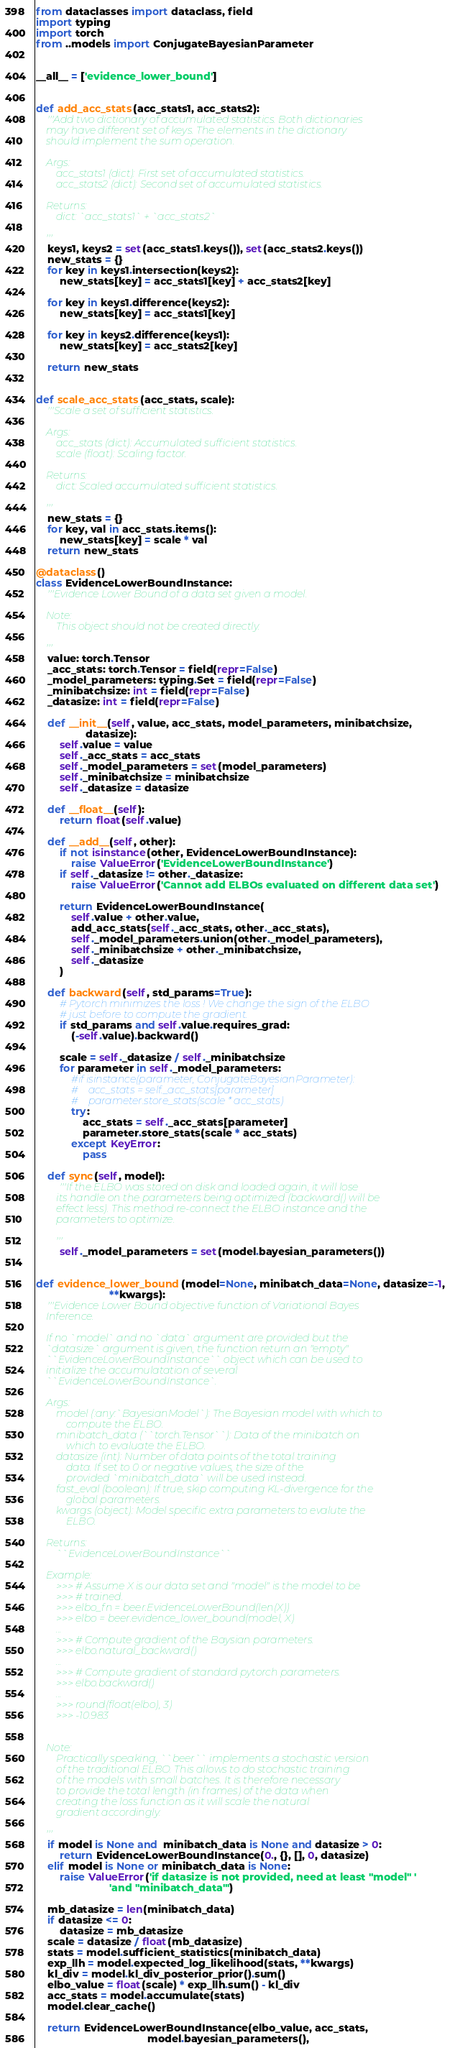Convert code to text. <code><loc_0><loc_0><loc_500><loc_500><_Python_>from dataclasses import dataclass, field
import typing
import torch
from ..models import ConjugateBayesianParameter


__all__ = ['evidence_lower_bound']


def add_acc_stats(acc_stats1, acc_stats2):
    '''Add two dictionary of accumulated statistics. Both dictionaries
    may have different set of keys. The elements in the dictionary
    should implement the sum operation.

    Args:
        acc_stats1 (dict): First set of accumulated statistics.
        acc_stats2 (dict): Second set of accumulated statistics.

    Returns:
        dict: `acc_stats1` + `acc_stats2`

    '''
    keys1, keys2 = set(acc_stats1.keys()), set(acc_stats2.keys())
    new_stats = {}
    for key in keys1.intersection(keys2):
        new_stats[key] = acc_stats1[key] + acc_stats2[key]

    for key in keys1.difference(keys2):
        new_stats[key] = acc_stats1[key]

    for key in keys2.difference(keys1):
        new_stats[key] = acc_stats2[key]

    return new_stats


def scale_acc_stats(acc_stats, scale):
    '''Scale a set of sufficient statistics.

    Args:
        acc_stats (dict): Accumulated sufficient statistics.
        scale (float): Scaling factor.

    Returns:
        dict: Scaled accumulated sufficient statistics.

    '''
    new_stats = {}
    for key, val in acc_stats.items():
        new_stats[key] = scale * val
    return new_stats

@dataclass()
class EvidenceLowerBoundInstance:
    '''Evidence Lower Bound of a data set given a model.

    Note:
        This object should not be created directly.

    '''
    value: torch.Tensor
    _acc_stats: torch.Tensor = field(repr=False)
    _model_parameters: typing.Set = field(repr=False)
    _minibatchsize: int = field(repr=False)
    _datasize: int = field(repr=False)

    def __init__(self, value, acc_stats, model_parameters, minibatchsize,
                 datasize):
        self.value = value
        self._acc_stats = acc_stats
        self._model_parameters = set(model_parameters)
        self._minibatchsize = minibatchsize
        self._datasize = datasize

    def __float__(self):
        return float(self.value)

    def __add__(self, other):
        if not isinstance(other, EvidenceLowerBoundInstance):
            raise ValueError('EvidenceLowerBoundInstance')
        if self._datasize != other._datasize:
            raise ValueError('Cannot add ELBOs evaluated on different data set')

        return EvidenceLowerBoundInstance(
            self.value + other.value,
            add_acc_stats(self._acc_stats, other._acc_stats),
            self._model_parameters.union(other._model_parameters),
            self._minibatchsize + other._minibatchsize,
            self._datasize
        )

    def backward(self, std_params=True):
        # Pytorch minimizes the loss ! We change the sign of the ELBO
        # just before to compute the gradient.
        if std_params and self.value.requires_grad:
            (-self.value).backward()

        scale = self._datasize / self._minibatchsize
        for parameter in self._model_parameters:
            #if isinstance(parameter, ConjugateBayesianParameter):
            #    acc_stats = self._acc_stats[parameter]
            #    parameter.store_stats(scale * acc_stats)
            try:
                acc_stats = self._acc_stats[parameter]
                parameter.store_stats(scale * acc_stats)
            except KeyError:
                pass

    def sync(self, model):
        '''If the ELBO was stored on disk and loaded again, it will lose
        its handle on the parameters being optimized (backward() will be
        effect less). This method re-connect the ELBO instance and the
        parameters to optimize.

        '''
        self._model_parameters = set(model.bayesian_parameters())


def evidence_lower_bound(model=None, minibatch_data=None, datasize=-1,
                         **kwargs):
    '''Evidence Lower Bound objective function of Variational Bayes
    Inference.

    If no `model` and no `data` argument are provided but the
    `datasize` argument is given, the function return an "empty"
    ``EvidenceLowerBoundInstance`` object which can be used to
    initialize the accumulatation of several
    ``EvidenceLowerBoundInstance`.

    Args:
        model (:any:`BayesianModel`): The Bayesian model with which to
            compute the ELBO.
        minibatch_data (``torch.Tensor``): Data of the minibatch on
            which to evaluate the ELBO.
        datasize (int): Number of data points of the total training
            data. If set to 0 or negative values, the size of the
            provided `minibatch_data` will be used instead.
        fast_eval (boolean): If true, skip computing KL-divergence for the
            global parameters.
        kwargs (object): Model specific extra parameters to evalute the
            ELBO.

    Returns:
        ``EvidenceLowerBoundInstance``

    Example:
        >>> # Assume X is our data set and "model" is the model to be
        >>> # trained.
        >>> elbo_fn = beer.EvidenceLowerBound(len(X))
        >>> elbo = beer.evidence_lower_bound(model, X)
        ...
        >>> # Compute gradient of the Baysian parameters.
        >>> elbo.natural_backward()
        ...
        >>> # Compute gradient of standard pytorch parameters.
        >>> elbo.backward()
        ...
        >>> round(float(elbo), 3)
        >>> -10.983


    Note:
        Practically speaking, ``beer`` implements a stochastic version
        of the traditional ELBO. This allows to do stochastic training
        of the models with small batches. It is therefore necessary
        to provide the total length (in frames) of the data when
        creating the loss function as it will scale the natural
        gradient accordingly.

    '''
    if model is None and  minibatch_data is None and datasize > 0:
        return EvidenceLowerBoundInstance(0., {}, [], 0, datasize)
    elif model is None or minibatch_data is None:
        raise ValueError('if datasize is not provided, need at least "model" '
                         'and "minibatch_data"')

    mb_datasize = len(minibatch_data)
    if datasize <= 0:
        datasize = mb_datasize
    scale = datasize / float(mb_datasize)
    stats = model.sufficient_statistics(minibatch_data)
    exp_llh = model.expected_log_likelihood(stats, **kwargs)
    kl_div = model.kl_div_posterior_prior().sum()
    elbo_value = float(scale) * exp_llh.sum() - kl_div
    acc_stats = model.accumulate(stats)
    model.clear_cache()

    return EvidenceLowerBoundInstance(elbo_value, acc_stats,
                                      model.bayesian_parameters(),</code> 